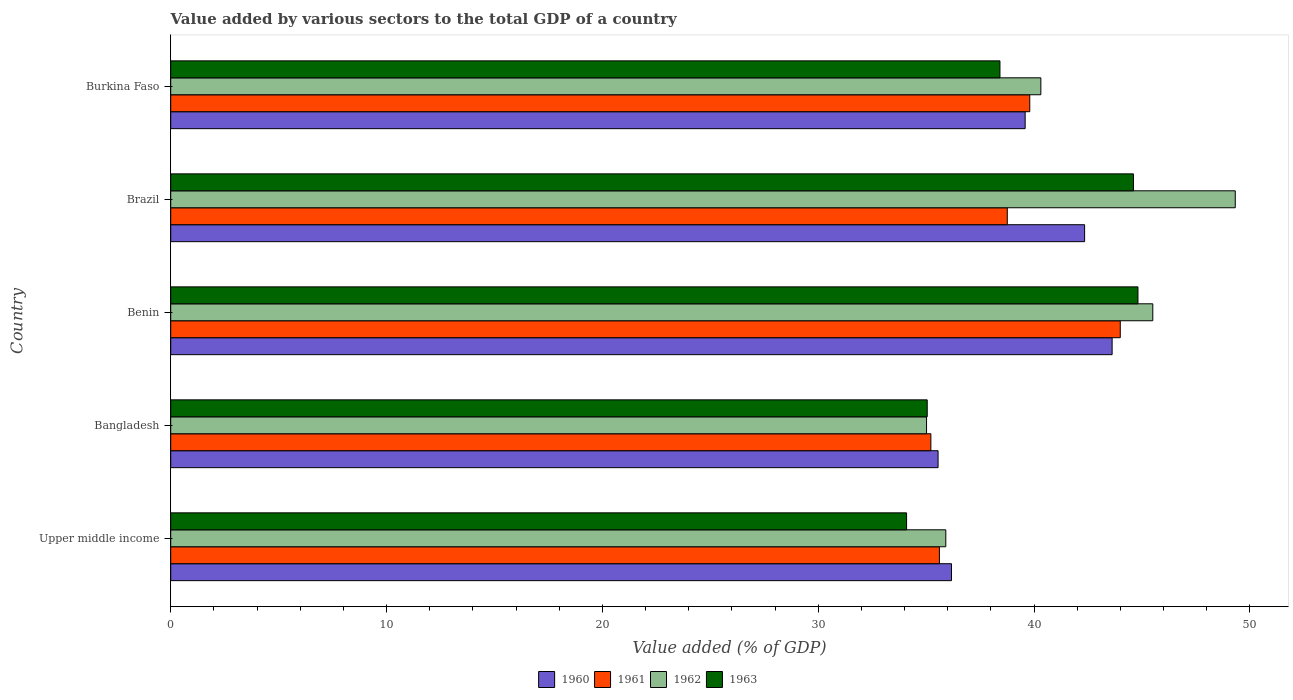How many groups of bars are there?
Keep it short and to the point. 5. Are the number of bars per tick equal to the number of legend labels?
Provide a succinct answer. Yes. Are the number of bars on each tick of the Y-axis equal?
Ensure brevity in your answer.  Yes. What is the label of the 1st group of bars from the top?
Make the answer very short. Burkina Faso. What is the value added by various sectors to the total GDP in 1961 in Burkina Faso?
Give a very brief answer. 39.8. Across all countries, what is the maximum value added by various sectors to the total GDP in 1960?
Keep it short and to the point. 43.62. Across all countries, what is the minimum value added by various sectors to the total GDP in 1962?
Give a very brief answer. 35.02. In which country was the value added by various sectors to the total GDP in 1963 maximum?
Your answer should be compact. Benin. In which country was the value added by various sectors to the total GDP in 1963 minimum?
Give a very brief answer. Upper middle income. What is the total value added by various sectors to the total GDP in 1963 in the graph?
Ensure brevity in your answer.  196.98. What is the difference between the value added by various sectors to the total GDP in 1963 in Bangladesh and that in Brazil?
Keep it short and to the point. -9.56. What is the difference between the value added by various sectors to the total GDP in 1963 in Burkina Faso and the value added by various sectors to the total GDP in 1961 in Benin?
Your response must be concise. -5.57. What is the average value added by various sectors to the total GDP in 1960 per country?
Provide a short and direct response. 39.45. What is the difference between the value added by various sectors to the total GDP in 1963 and value added by various sectors to the total GDP in 1960 in Burkina Faso?
Your answer should be compact. -1.17. In how many countries, is the value added by various sectors to the total GDP in 1962 greater than 32 %?
Give a very brief answer. 5. What is the ratio of the value added by various sectors to the total GDP in 1963 in Burkina Faso to that in Upper middle income?
Keep it short and to the point. 1.13. Is the value added by various sectors to the total GDP in 1961 in Bangladesh less than that in Benin?
Make the answer very short. Yes. What is the difference between the highest and the second highest value added by various sectors to the total GDP in 1961?
Make the answer very short. 4.19. What is the difference between the highest and the lowest value added by various sectors to the total GDP in 1962?
Make the answer very short. 14.3. Is the sum of the value added by various sectors to the total GDP in 1960 in Bangladesh and Upper middle income greater than the maximum value added by various sectors to the total GDP in 1962 across all countries?
Give a very brief answer. Yes. What does the 4th bar from the bottom in Bangladesh represents?
Offer a very short reply. 1963. What is the difference between two consecutive major ticks on the X-axis?
Ensure brevity in your answer.  10. Are the values on the major ticks of X-axis written in scientific E-notation?
Your answer should be very brief. No. Does the graph contain grids?
Offer a very short reply. No. How many legend labels are there?
Your response must be concise. 4. What is the title of the graph?
Provide a succinct answer. Value added by various sectors to the total GDP of a country. What is the label or title of the X-axis?
Keep it short and to the point. Value added (% of GDP). What is the Value added (% of GDP) of 1960 in Upper middle income?
Make the answer very short. 36.17. What is the Value added (% of GDP) of 1961 in Upper middle income?
Provide a succinct answer. 35.61. What is the Value added (% of GDP) of 1962 in Upper middle income?
Offer a very short reply. 35.91. What is the Value added (% of GDP) of 1963 in Upper middle income?
Keep it short and to the point. 34.09. What is the Value added (% of GDP) in 1960 in Bangladesh?
Keep it short and to the point. 35.55. What is the Value added (% of GDP) of 1961 in Bangladesh?
Keep it short and to the point. 35.22. What is the Value added (% of GDP) in 1962 in Bangladesh?
Keep it short and to the point. 35.02. What is the Value added (% of GDP) of 1963 in Bangladesh?
Your answer should be very brief. 35.05. What is the Value added (% of GDP) in 1960 in Benin?
Provide a succinct answer. 43.62. What is the Value added (% of GDP) in 1961 in Benin?
Your answer should be very brief. 43.99. What is the Value added (% of GDP) of 1962 in Benin?
Offer a very short reply. 45.5. What is the Value added (% of GDP) in 1963 in Benin?
Offer a very short reply. 44.81. What is the Value added (% of GDP) in 1960 in Brazil?
Offer a very short reply. 42.34. What is the Value added (% of GDP) of 1961 in Brazil?
Provide a short and direct response. 38.76. What is the Value added (% of GDP) of 1962 in Brazil?
Make the answer very short. 49.32. What is the Value added (% of GDP) of 1963 in Brazil?
Ensure brevity in your answer.  44.6. What is the Value added (% of GDP) of 1960 in Burkina Faso?
Your answer should be very brief. 39.59. What is the Value added (% of GDP) of 1961 in Burkina Faso?
Provide a succinct answer. 39.8. What is the Value added (% of GDP) of 1962 in Burkina Faso?
Your answer should be very brief. 40.31. What is the Value added (% of GDP) in 1963 in Burkina Faso?
Offer a terse response. 38.42. Across all countries, what is the maximum Value added (% of GDP) of 1960?
Your answer should be very brief. 43.62. Across all countries, what is the maximum Value added (% of GDP) of 1961?
Provide a succinct answer. 43.99. Across all countries, what is the maximum Value added (% of GDP) of 1962?
Your response must be concise. 49.32. Across all countries, what is the maximum Value added (% of GDP) in 1963?
Provide a succinct answer. 44.81. Across all countries, what is the minimum Value added (% of GDP) in 1960?
Give a very brief answer. 35.55. Across all countries, what is the minimum Value added (% of GDP) of 1961?
Make the answer very short. 35.22. Across all countries, what is the minimum Value added (% of GDP) in 1962?
Offer a very short reply. 35.02. Across all countries, what is the minimum Value added (% of GDP) in 1963?
Ensure brevity in your answer.  34.09. What is the total Value added (% of GDP) of 1960 in the graph?
Offer a terse response. 197.27. What is the total Value added (% of GDP) in 1961 in the graph?
Provide a short and direct response. 193.38. What is the total Value added (% of GDP) of 1962 in the graph?
Offer a very short reply. 206.06. What is the total Value added (% of GDP) in 1963 in the graph?
Offer a very short reply. 196.98. What is the difference between the Value added (% of GDP) of 1960 in Upper middle income and that in Bangladesh?
Keep it short and to the point. 0.62. What is the difference between the Value added (% of GDP) in 1961 in Upper middle income and that in Bangladesh?
Ensure brevity in your answer.  0.4. What is the difference between the Value added (% of GDP) of 1962 in Upper middle income and that in Bangladesh?
Make the answer very short. 0.89. What is the difference between the Value added (% of GDP) of 1963 in Upper middle income and that in Bangladesh?
Offer a very short reply. -0.96. What is the difference between the Value added (% of GDP) of 1960 in Upper middle income and that in Benin?
Ensure brevity in your answer.  -7.44. What is the difference between the Value added (% of GDP) of 1961 in Upper middle income and that in Benin?
Give a very brief answer. -8.38. What is the difference between the Value added (% of GDP) of 1962 in Upper middle income and that in Benin?
Offer a terse response. -9.59. What is the difference between the Value added (% of GDP) in 1963 in Upper middle income and that in Benin?
Provide a short and direct response. -10.72. What is the difference between the Value added (% of GDP) in 1960 in Upper middle income and that in Brazil?
Keep it short and to the point. -6.17. What is the difference between the Value added (% of GDP) of 1961 in Upper middle income and that in Brazil?
Your response must be concise. -3.15. What is the difference between the Value added (% of GDP) in 1962 in Upper middle income and that in Brazil?
Your answer should be very brief. -13.41. What is the difference between the Value added (% of GDP) in 1963 in Upper middle income and that in Brazil?
Give a very brief answer. -10.51. What is the difference between the Value added (% of GDP) of 1960 in Upper middle income and that in Burkina Faso?
Your response must be concise. -3.41. What is the difference between the Value added (% of GDP) in 1961 in Upper middle income and that in Burkina Faso?
Provide a short and direct response. -4.19. What is the difference between the Value added (% of GDP) in 1962 in Upper middle income and that in Burkina Faso?
Your answer should be very brief. -4.4. What is the difference between the Value added (% of GDP) in 1963 in Upper middle income and that in Burkina Faso?
Your answer should be compact. -4.33. What is the difference between the Value added (% of GDP) in 1960 in Bangladesh and that in Benin?
Give a very brief answer. -8.06. What is the difference between the Value added (% of GDP) of 1961 in Bangladesh and that in Benin?
Keep it short and to the point. -8.78. What is the difference between the Value added (% of GDP) in 1962 in Bangladesh and that in Benin?
Your answer should be very brief. -10.48. What is the difference between the Value added (% of GDP) in 1963 in Bangladesh and that in Benin?
Your answer should be very brief. -9.76. What is the difference between the Value added (% of GDP) in 1960 in Bangladesh and that in Brazil?
Keep it short and to the point. -6.79. What is the difference between the Value added (% of GDP) of 1961 in Bangladesh and that in Brazil?
Your answer should be compact. -3.54. What is the difference between the Value added (% of GDP) in 1962 in Bangladesh and that in Brazil?
Provide a short and direct response. -14.3. What is the difference between the Value added (% of GDP) in 1963 in Bangladesh and that in Brazil?
Offer a terse response. -9.56. What is the difference between the Value added (% of GDP) in 1960 in Bangladesh and that in Burkina Faso?
Your answer should be compact. -4.03. What is the difference between the Value added (% of GDP) of 1961 in Bangladesh and that in Burkina Faso?
Give a very brief answer. -4.58. What is the difference between the Value added (% of GDP) of 1962 in Bangladesh and that in Burkina Faso?
Provide a succinct answer. -5.3. What is the difference between the Value added (% of GDP) of 1963 in Bangladesh and that in Burkina Faso?
Ensure brevity in your answer.  -3.37. What is the difference between the Value added (% of GDP) of 1960 in Benin and that in Brazil?
Provide a succinct answer. 1.27. What is the difference between the Value added (% of GDP) in 1961 in Benin and that in Brazil?
Provide a succinct answer. 5.23. What is the difference between the Value added (% of GDP) in 1962 in Benin and that in Brazil?
Your answer should be very brief. -3.82. What is the difference between the Value added (% of GDP) of 1963 in Benin and that in Brazil?
Offer a terse response. 0.21. What is the difference between the Value added (% of GDP) in 1960 in Benin and that in Burkina Faso?
Offer a terse response. 4.03. What is the difference between the Value added (% of GDP) in 1961 in Benin and that in Burkina Faso?
Offer a very short reply. 4.19. What is the difference between the Value added (% of GDP) of 1962 in Benin and that in Burkina Faso?
Ensure brevity in your answer.  5.19. What is the difference between the Value added (% of GDP) in 1963 in Benin and that in Burkina Faso?
Your answer should be very brief. 6.39. What is the difference between the Value added (% of GDP) of 1960 in Brazil and that in Burkina Faso?
Your answer should be very brief. 2.75. What is the difference between the Value added (% of GDP) in 1961 in Brazil and that in Burkina Faso?
Offer a very short reply. -1.04. What is the difference between the Value added (% of GDP) in 1962 in Brazil and that in Burkina Faso?
Give a very brief answer. 9.01. What is the difference between the Value added (% of GDP) of 1963 in Brazil and that in Burkina Faso?
Your answer should be compact. 6.19. What is the difference between the Value added (% of GDP) in 1960 in Upper middle income and the Value added (% of GDP) in 1961 in Bangladesh?
Provide a short and direct response. 0.96. What is the difference between the Value added (% of GDP) in 1960 in Upper middle income and the Value added (% of GDP) in 1962 in Bangladesh?
Offer a terse response. 1.16. What is the difference between the Value added (% of GDP) in 1960 in Upper middle income and the Value added (% of GDP) in 1963 in Bangladesh?
Your answer should be very brief. 1.12. What is the difference between the Value added (% of GDP) of 1961 in Upper middle income and the Value added (% of GDP) of 1962 in Bangladesh?
Keep it short and to the point. 0.6. What is the difference between the Value added (% of GDP) in 1961 in Upper middle income and the Value added (% of GDP) in 1963 in Bangladesh?
Offer a terse response. 0.56. What is the difference between the Value added (% of GDP) of 1962 in Upper middle income and the Value added (% of GDP) of 1963 in Bangladesh?
Offer a very short reply. 0.86. What is the difference between the Value added (% of GDP) of 1960 in Upper middle income and the Value added (% of GDP) of 1961 in Benin?
Provide a short and direct response. -7.82. What is the difference between the Value added (% of GDP) of 1960 in Upper middle income and the Value added (% of GDP) of 1962 in Benin?
Your answer should be very brief. -9.33. What is the difference between the Value added (% of GDP) in 1960 in Upper middle income and the Value added (% of GDP) in 1963 in Benin?
Provide a short and direct response. -8.64. What is the difference between the Value added (% of GDP) in 1961 in Upper middle income and the Value added (% of GDP) in 1962 in Benin?
Provide a succinct answer. -9.89. What is the difference between the Value added (% of GDP) in 1961 in Upper middle income and the Value added (% of GDP) in 1963 in Benin?
Give a very brief answer. -9.2. What is the difference between the Value added (% of GDP) in 1962 in Upper middle income and the Value added (% of GDP) in 1963 in Benin?
Provide a short and direct response. -8.9. What is the difference between the Value added (% of GDP) of 1960 in Upper middle income and the Value added (% of GDP) of 1961 in Brazil?
Offer a very short reply. -2.58. What is the difference between the Value added (% of GDP) in 1960 in Upper middle income and the Value added (% of GDP) in 1962 in Brazil?
Give a very brief answer. -13.15. What is the difference between the Value added (% of GDP) of 1960 in Upper middle income and the Value added (% of GDP) of 1963 in Brazil?
Your answer should be compact. -8.43. What is the difference between the Value added (% of GDP) in 1961 in Upper middle income and the Value added (% of GDP) in 1962 in Brazil?
Your answer should be compact. -13.71. What is the difference between the Value added (% of GDP) in 1961 in Upper middle income and the Value added (% of GDP) in 1963 in Brazil?
Ensure brevity in your answer.  -8.99. What is the difference between the Value added (% of GDP) of 1962 in Upper middle income and the Value added (% of GDP) of 1963 in Brazil?
Offer a very short reply. -8.69. What is the difference between the Value added (% of GDP) in 1960 in Upper middle income and the Value added (% of GDP) in 1961 in Burkina Faso?
Provide a short and direct response. -3.63. What is the difference between the Value added (% of GDP) of 1960 in Upper middle income and the Value added (% of GDP) of 1962 in Burkina Faso?
Your answer should be compact. -4.14. What is the difference between the Value added (% of GDP) of 1960 in Upper middle income and the Value added (% of GDP) of 1963 in Burkina Faso?
Offer a terse response. -2.24. What is the difference between the Value added (% of GDP) of 1961 in Upper middle income and the Value added (% of GDP) of 1963 in Burkina Faso?
Ensure brevity in your answer.  -2.81. What is the difference between the Value added (% of GDP) in 1962 in Upper middle income and the Value added (% of GDP) in 1963 in Burkina Faso?
Offer a very short reply. -2.51. What is the difference between the Value added (% of GDP) in 1960 in Bangladesh and the Value added (% of GDP) in 1961 in Benin?
Your answer should be compact. -8.44. What is the difference between the Value added (% of GDP) in 1960 in Bangladesh and the Value added (% of GDP) in 1962 in Benin?
Your answer should be compact. -9.95. What is the difference between the Value added (% of GDP) in 1960 in Bangladesh and the Value added (% of GDP) in 1963 in Benin?
Ensure brevity in your answer.  -9.26. What is the difference between the Value added (% of GDP) of 1961 in Bangladesh and the Value added (% of GDP) of 1962 in Benin?
Your answer should be very brief. -10.28. What is the difference between the Value added (% of GDP) of 1961 in Bangladesh and the Value added (% of GDP) of 1963 in Benin?
Your answer should be very brief. -9.59. What is the difference between the Value added (% of GDP) of 1962 in Bangladesh and the Value added (% of GDP) of 1963 in Benin?
Provide a succinct answer. -9.79. What is the difference between the Value added (% of GDP) of 1960 in Bangladesh and the Value added (% of GDP) of 1961 in Brazil?
Your answer should be very brief. -3.21. What is the difference between the Value added (% of GDP) in 1960 in Bangladesh and the Value added (% of GDP) in 1962 in Brazil?
Provide a succinct answer. -13.77. What is the difference between the Value added (% of GDP) in 1960 in Bangladesh and the Value added (% of GDP) in 1963 in Brazil?
Your answer should be compact. -9.05. What is the difference between the Value added (% of GDP) in 1961 in Bangladesh and the Value added (% of GDP) in 1962 in Brazil?
Your answer should be very brief. -14.1. What is the difference between the Value added (% of GDP) in 1961 in Bangladesh and the Value added (% of GDP) in 1963 in Brazil?
Provide a short and direct response. -9.39. What is the difference between the Value added (% of GDP) in 1962 in Bangladesh and the Value added (% of GDP) in 1963 in Brazil?
Your response must be concise. -9.59. What is the difference between the Value added (% of GDP) of 1960 in Bangladesh and the Value added (% of GDP) of 1961 in Burkina Faso?
Make the answer very short. -4.25. What is the difference between the Value added (% of GDP) of 1960 in Bangladesh and the Value added (% of GDP) of 1962 in Burkina Faso?
Offer a terse response. -4.76. What is the difference between the Value added (% of GDP) in 1960 in Bangladesh and the Value added (% of GDP) in 1963 in Burkina Faso?
Your answer should be compact. -2.87. What is the difference between the Value added (% of GDP) of 1961 in Bangladesh and the Value added (% of GDP) of 1962 in Burkina Faso?
Offer a very short reply. -5.1. What is the difference between the Value added (% of GDP) of 1961 in Bangladesh and the Value added (% of GDP) of 1963 in Burkina Faso?
Provide a short and direct response. -3.2. What is the difference between the Value added (% of GDP) in 1962 in Bangladesh and the Value added (% of GDP) in 1963 in Burkina Faso?
Make the answer very short. -3.4. What is the difference between the Value added (% of GDP) in 1960 in Benin and the Value added (% of GDP) in 1961 in Brazil?
Your answer should be very brief. 4.86. What is the difference between the Value added (% of GDP) of 1960 in Benin and the Value added (% of GDP) of 1962 in Brazil?
Keep it short and to the point. -5.71. What is the difference between the Value added (% of GDP) in 1960 in Benin and the Value added (% of GDP) in 1963 in Brazil?
Provide a short and direct response. -0.99. What is the difference between the Value added (% of GDP) in 1961 in Benin and the Value added (% of GDP) in 1962 in Brazil?
Your answer should be very brief. -5.33. What is the difference between the Value added (% of GDP) in 1961 in Benin and the Value added (% of GDP) in 1963 in Brazil?
Offer a very short reply. -0.61. What is the difference between the Value added (% of GDP) in 1962 in Benin and the Value added (% of GDP) in 1963 in Brazil?
Offer a very short reply. 0.89. What is the difference between the Value added (% of GDP) in 1960 in Benin and the Value added (% of GDP) in 1961 in Burkina Faso?
Provide a short and direct response. 3.82. What is the difference between the Value added (% of GDP) of 1960 in Benin and the Value added (% of GDP) of 1962 in Burkina Faso?
Ensure brevity in your answer.  3.3. What is the difference between the Value added (% of GDP) of 1960 in Benin and the Value added (% of GDP) of 1963 in Burkina Faso?
Keep it short and to the point. 5.2. What is the difference between the Value added (% of GDP) in 1961 in Benin and the Value added (% of GDP) in 1962 in Burkina Faso?
Give a very brief answer. 3.68. What is the difference between the Value added (% of GDP) in 1961 in Benin and the Value added (% of GDP) in 1963 in Burkina Faso?
Keep it short and to the point. 5.57. What is the difference between the Value added (% of GDP) in 1962 in Benin and the Value added (% of GDP) in 1963 in Burkina Faso?
Provide a succinct answer. 7.08. What is the difference between the Value added (% of GDP) of 1960 in Brazil and the Value added (% of GDP) of 1961 in Burkina Faso?
Offer a very short reply. 2.54. What is the difference between the Value added (% of GDP) of 1960 in Brazil and the Value added (% of GDP) of 1962 in Burkina Faso?
Provide a short and direct response. 2.03. What is the difference between the Value added (% of GDP) in 1960 in Brazil and the Value added (% of GDP) in 1963 in Burkina Faso?
Ensure brevity in your answer.  3.92. What is the difference between the Value added (% of GDP) of 1961 in Brazil and the Value added (% of GDP) of 1962 in Burkina Faso?
Your response must be concise. -1.55. What is the difference between the Value added (% of GDP) in 1961 in Brazil and the Value added (% of GDP) in 1963 in Burkina Faso?
Your response must be concise. 0.34. What is the difference between the Value added (% of GDP) of 1962 in Brazil and the Value added (% of GDP) of 1963 in Burkina Faso?
Your response must be concise. 10.9. What is the average Value added (% of GDP) of 1960 per country?
Your answer should be compact. 39.45. What is the average Value added (% of GDP) of 1961 per country?
Provide a short and direct response. 38.68. What is the average Value added (% of GDP) in 1962 per country?
Keep it short and to the point. 41.21. What is the average Value added (% of GDP) of 1963 per country?
Make the answer very short. 39.4. What is the difference between the Value added (% of GDP) of 1960 and Value added (% of GDP) of 1961 in Upper middle income?
Provide a succinct answer. 0.56. What is the difference between the Value added (% of GDP) of 1960 and Value added (% of GDP) of 1962 in Upper middle income?
Keep it short and to the point. 0.26. What is the difference between the Value added (% of GDP) of 1960 and Value added (% of GDP) of 1963 in Upper middle income?
Provide a succinct answer. 2.08. What is the difference between the Value added (% of GDP) of 1961 and Value added (% of GDP) of 1962 in Upper middle income?
Offer a very short reply. -0.3. What is the difference between the Value added (% of GDP) of 1961 and Value added (% of GDP) of 1963 in Upper middle income?
Give a very brief answer. 1.52. What is the difference between the Value added (% of GDP) of 1962 and Value added (% of GDP) of 1963 in Upper middle income?
Give a very brief answer. 1.82. What is the difference between the Value added (% of GDP) of 1960 and Value added (% of GDP) of 1961 in Bangladesh?
Offer a terse response. 0.33. What is the difference between the Value added (% of GDP) of 1960 and Value added (% of GDP) of 1962 in Bangladesh?
Keep it short and to the point. 0.53. What is the difference between the Value added (% of GDP) in 1960 and Value added (% of GDP) in 1963 in Bangladesh?
Provide a succinct answer. 0.5. What is the difference between the Value added (% of GDP) in 1961 and Value added (% of GDP) in 1962 in Bangladesh?
Your answer should be very brief. 0.2. What is the difference between the Value added (% of GDP) of 1961 and Value added (% of GDP) of 1963 in Bangladesh?
Your answer should be very brief. 0.17. What is the difference between the Value added (% of GDP) in 1962 and Value added (% of GDP) in 1963 in Bangladesh?
Give a very brief answer. -0.03. What is the difference between the Value added (% of GDP) in 1960 and Value added (% of GDP) in 1961 in Benin?
Your answer should be very brief. -0.38. What is the difference between the Value added (% of GDP) in 1960 and Value added (% of GDP) in 1962 in Benin?
Your answer should be compact. -1.88. What is the difference between the Value added (% of GDP) in 1960 and Value added (% of GDP) in 1963 in Benin?
Your response must be concise. -1.2. What is the difference between the Value added (% of GDP) in 1961 and Value added (% of GDP) in 1962 in Benin?
Provide a succinct answer. -1.51. What is the difference between the Value added (% of GDP) of 1961 and Value added (% of GDP) of 1963 in Benin?
Your answer should be very brief. -0.82. What is the difference between the Value added (% of GDP) in 1962 and Value added (% of GDP) in 1963 in Benin?
Provide a succinct answer. 0.69. What is the difference between the Value added (% of GDP) of 1960 and Value added (% of GDP) of 1961 in Brazil?
Make the answer very short. 3.58. What is the difference between the Value added (% of GDP) of 1960 and Value added (% of GDP) of 1962 in Brazil?
Your answer should be very brief. -6.98. What is the difference between the Value added (% of GDP) in 1960 and Value added (% of GDP) in 1963 in Brazil?
Keep it short and to the point. -2.26. What is the difference between the Value added (% of GDP) in 1961 and Value added (% of GDP) in 1962 in Brazil?
Your response must be concise. -10.56. What is the difference between the Value added (% of GDP) in 1961 and Value added (% of GDP) in 1963 in Brazil?
Give a very brief answer. -5.85. What is the difference between the Value added (% of GDP) in 1962 and Value added (% of GDP) in 1963 in Brazil?
Your answer should be compact. 4.72. What is the difference between the Value added (% of GDP) of 1960 and Value added (% of GDP) of 1961 in Burkina Faso?
Your answer should be very brief. -0.21. What is the difference between the Value added (% of GDP) of 1960 and Value added (% of GDP) of 1962 in Burkina Faso?
Provide a short and direct response. -0.73. What is the difference between the Value added (% of GDP) of 1960 and Value added (% of GDP) of 1963 in Burkina Faso?
Your response must be concise. 1.17. What is the difference between the Value added (% of GDP) of 1961 and Value added (% of GDP) of 1962 in Burkina Faso?
Offer a very short reply. -0.51. What is the difference between the Value added (% of GDP) of 1961 and Value added (% of GDP) of 1963 in Burkina Faso?
Provide a short and direct response. 1.38. What is the difference between the Value added (% of GDP) in 1962 and Value added (% of GDP) in 1963 in Burkina Faso?
Offer a very short reply. 1.89. What is the ratio of the Value added (% of GDP) of 1960 in Upper middle income to that in Bangladesh?
Provide a succinct answer. 1.02. What is the ratio of the Value added (% of GDP) of 1961 in Upper middle income to that in Bangladesh?
Keep it short and to the point. 1.01. What is the ratio of the Value added (% of GDP) in 1962 in Upper middle income to that in Bangladesh?
Ensure brevity in your answer.  1.03. What is the ratio of the Value added (% of GDP) in 1963 in Upper middle income to that in Bangladesh?
Provide a succinct answer. 0.97. What is the ratio of the Value added (% of GDP) in 1960 in Upper middle income to that in Benin?
Provide a short and direct response. 0.83. What is the ratio of the Value added (% of GDP) in 1961 in Upper middle income to that in Benin?
Provide a succinct answer. 0.81. What is the ratio of the Value added (% of GDP) in 1962 in Upper middle income to that in Benin?
Provide a short and direct response. 0.79. What is the ratio of the Value added (% of GDP) in 1963 in Upper middle income to that in Benin?
Give a very brief answer. 0.76. What is the ratio of the Value added (% of GDP) of 1960 in Upper middle income to that in Brazil?
Ensure brevity in your answer.  0.85. What is the ratio of the Value added (% of GDP) in 1961 in Upper middle income to that in Brazil?
Give a very brief answer. 0.92. What is the ratio of the Value added (% of GDP) in 1962 in Upper middle income to that in Brazil?
Offer a very short reply. 0.73. What is the ratio of the Value added (% of GDP) in 1963 in Upper middle income to that in Brazil?
Offer a very short reply. 0.76. What is the ratio of the Value added (% of GDP) of 1960 in Upper middle income to that in Burkina Faso?
Offer a very short reply. 0.91. What is the ratio of the Value added (% of GDP) in 1961 in Upper middle income to that in Burkina Faso?
Your response must be concise. 0.89. What is the ratio of the Value added (% of GDP) in 1962 in Upper middle income to that in Burkina Faso?
Your answer should be very brief. 0.89. What is the ratio of the Value added (% of GDP) of 1963 in Upper middle income to that in Burkina Faso?
Offer a terse response. 0.89. What is the ratio of the Value added (% of GDP) of 1960 in Bangladesh to that in Benin?
Offer a terse response. 0.82. What is the ratio of the Value added (% of GDP) of 1961 in Bangladesh to that in Benin?
Offer a very short reply. 0.8. What is the ratio of the Value added (% of GDP) of 1962 in Bangladesh to that in Benin?
Keep it short and to the point. 0.77. What is the ratio of the Value added (% of GDP) of 1963 in Bangladesh to that in Benin?
Offer a very short reply. 0.78. What is the ratio of the Value added (% of GDP) in 1960 in Bangladesh to that in Brazil?
Keep it short and to the point. 0.84. What is the ratio of the Value added (% of GDP) of 1961 in Bangladesh to that in Brazil?
Ensure brevity in your answer.  0.91. What is the ratio of the Value added (% of GDP) of 1962 in Bangladesh to that in Brazil?
Offer a very short reply. 0.71. What is the ratio of the Value added (% of GDP) of 1963 in Bangladesh to that in Brazil?
Give a very brief answer. 0.79. What is the ratio of the Value added (% of GDP) of 1960 in Bangladesh to that in Burkina Faso?
Offer a very short reply. 0.9. What is the ratio of the Value added (% of GDP) of 1961 in Bangladesh to that in Burkina Faso?
Your answer should be compact. 0.88. What is the ratio of the Value added (% of GDP) in 1962 in Bangladesh to that in Burkina Faso?
Your answer should be very brief. 0.87. What is the ratio of the Value added (% of GDP) of 1963 in Bangladesh to that in Burkina Faso?
Provide a succinct answer. 0.91. What is the ratio of the Value added (% of GDP) in 1960 in Benin to that in Brazil?
Your answer should be very brief. 1.03. What is the ratio of the Value added (% of GDP) in 1961 in Benin to that in Brazil?
Your answer should be very brief. 1.14. What is the ratio of the Value added (% of GDP) in 1962 in Benin to that in Brazil?
Provide a short and direct response. 0.92. What is the ratio of the Value added (% of GDP) of 1960 in Benin to that in Burkina Faso?
Your answer should be very brief. 1.1. What is the ratio of the Value added (% of GDP) in 1961 in Benin to that in Burkina Faso?
Offer a terse response. 1.11. What is the ratio of the Value added (% of GDP) of 1962 in Benin to that in Burkina Faso?
Offer a terse response. 1.13. What is the ratio of the Value added (% of GDP) in 1963 in Benin to that in Burkina Faso?
Provide a succinct answer. 1.17. What is the ratio of the Value added (% of GDP) of 1960 in Brazil to that in Burkina Faso?
Offer a very short reply. 1.07. What is the ratio of the Value added (% of GDP) of 1961 in Brazil to that in Burkina Faso?
Provide a succinct answer. 0.97. What is the ratio of the Value added (% of GDP) in 1962 in Brazil to that in Burkina Faso?
Provide a short and direct response. 1.22. What is the ratio of the Value added (% of GDP) of 1963 in Brazil to that in Burkina Faso?
Your answer should be compact. 1.16. What is the difference between the highest and the second highest Value added (% of GDP) in 1960?
Provide a succinct answer. 1.27. What is the difference between the highest and the second highest Value added (% of GDP) of 1961?
Your answer should be very brief. 4.19. What is the difference between the highest and the second highest Value added (% of GDP) of 1962?
Offer a very short reply. 3.82. What is the difference between the highest and the second highest Value added (% of GDP) of 1963?
Ensure brevity in your answer.  0.21. What is the difference between the highest and the lowest Value added (% of GDP) of 1960?
Your answer should be very brief. 8.06. What is the difference between the highest and the lowest Value added (% of GDP) in 1961?
Offer a terse response. 8.78. What is the difference between the highest and the lowest Value added (% of GDP) of 1962?
Give a very brief answer. 14.3. What is the difference between the highest and the lowest Value added (% of GDP) of 1963?
Your answer should be very brief. 10.72. 